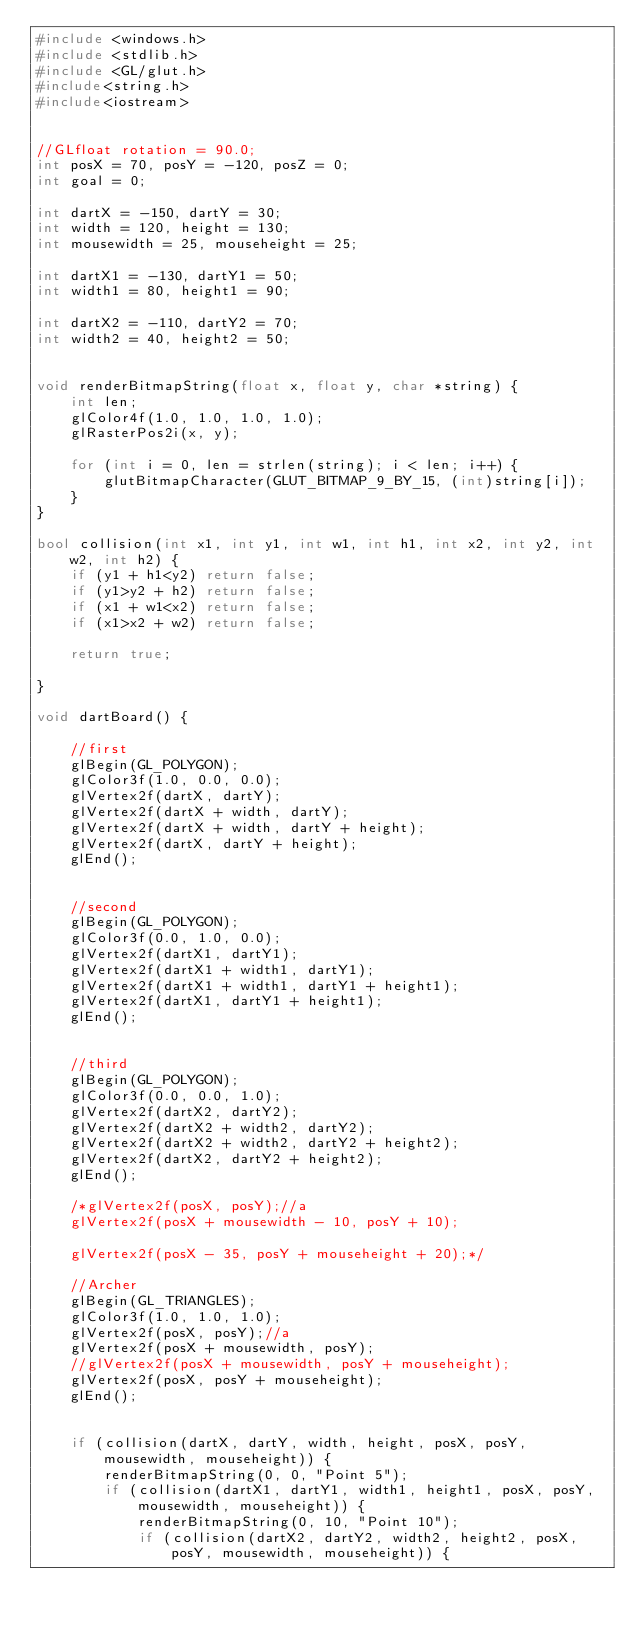<code> <loc_0><loc_0><loc_500><loc_500><_C++_>#include <windows.h>
#include <stdlib.h>
#include <GL/glut.h>
#include<string.h>
#include<iostream>


//GLfloat rotation = 90.0;
int posX = 70, posY = -120, posZ = 0;
int goal = 0;

int dartX = -150, dartY = 30;
int width = 120, height = 130;
int mousewidth = 25, mouseheight = 25;

int dartX1 = -130, dartY1 = 50;
int width1 = 80, height1 = 90;

int dartX2 = -110, dartY2 = 70;
int width2 = 40, height2 = 50;


void renderBitmapString(float x, float y, char *string) {
	int len;
	glColor4f(1.0, 1.0, 1.0, 1.0);
	glRasterPos2i(x, y);

	for (int i = 0, len = strlen(string); i < len; i++) {
		glutBitmapCharacter(GLUT_BITMAP_9_BY_15, (int)string[i]);
	}
}

bool collision(int x1, int y1, int w1, int h1, int x2, int y2, int w2, int h2) {
	if (y1 + h1<y2) return false;
	if (y1>y2 + h2) return false;
	if (x1 + w1<x2) return false;
	if (x1>x2 + w2) return false;

	return true;

}

void dartBoard() {

	//first 
	glBegin(GL_POLYGON);
	glColor3f(1.0, 0.0, 0.0);
	glVertex2f(dartX, dartY);
	glVertex2f(dartX + width, dartY);
	glVertex2f(dartX + width, dartY + height);
	glVertex2f(dartX, dartY + height);
	glEnd();
	

	//second 
	glBegin(GL_POLYGON);
	glColor3f(0.0, 1.0, 0.0);
	glVertex2f(dartX1, dartY1);
	glVertex2f(dartX1 + width1, dartY1);
	glVertex2f(dartX1 + width1, dartY1 + height1);
	glVertex2f(dartX1, dartY1 + height1);
	glEnd();


	//third 
	glBegin(GL_POLYGON);
	glColor3f(0.0, 0.0, 1.0);
	glVertex2f(dartX2, dartY2);
	glVertex2f(dartX2 + width2, dartY2);
	glVertex2f(dartX2 + width2, dartY2 + height2);
	glVertex2f(dartX2, dartY2 + height2);
	glEnd();

	/*glVertex2f(posX, posY);//a
	glVertex2f(posX + mousewidth - 10, posY + 10);
												  
	glVertex2f(posX - 35, posY + mouseheight + 20);*/

	//Archer
	glBegin(GL_TRIANGLES);
	glColor3f(1.0, 1.0, 1.0);
	glVertex2f(posX, posY);//a
	glVertex2f(posX + mousewidth, posY);
	//glVertex2f(posX + mousewidth, posY + mouseheight);
	glVertex2f(posX, posY + mouseheight);
	glEnd();


	if (collision(dartX, dartY, width, height, posX, posY, mousewidth, mouseheight)) {
		renderBitmapString(0, 0, "Point 5");
		if (collision(dartX1, dartY1, width1, height1, posX, posY, mousewidth, mouseheight)) {
			renderBitmapString(0, 10, "Point 10");
			if (collision(dartX2, dartY2, width2, height2, posX, posY, mousewidth, mouseheight)) {</code> 